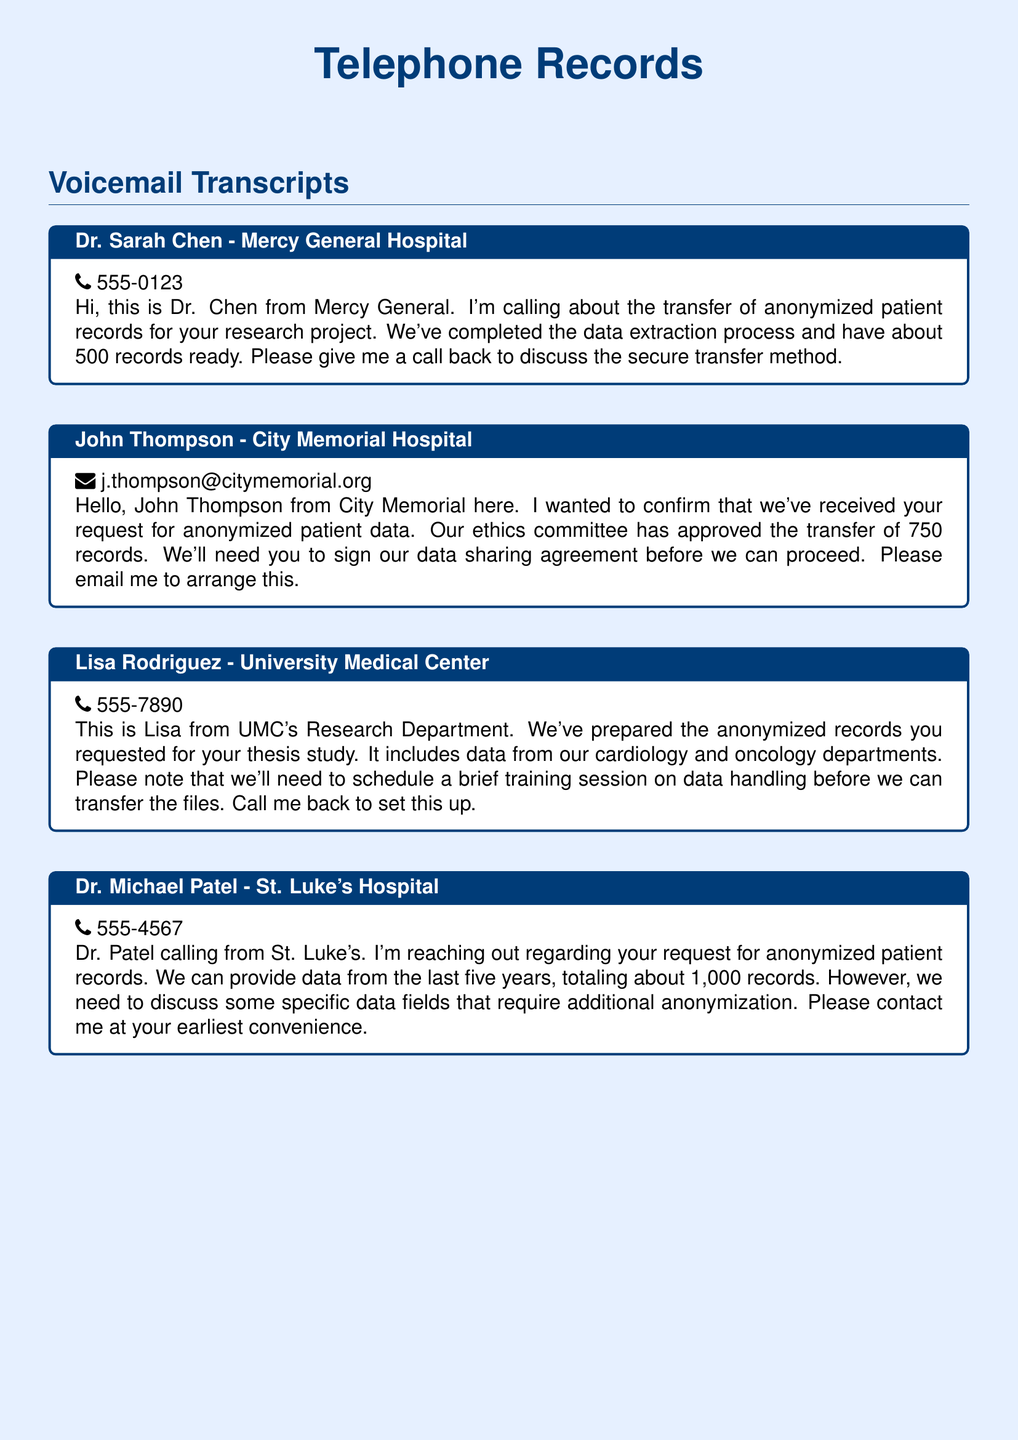What is the name of the first caller? The first caller is Dr. Sarah Chen, identified by the header of the voicemail.
Answer: Dr. Sarah Chen How many records did Mercy General Hospital prepare? The voicemail indicates that Mercy General has approximately 500 records ready for transfer.
Answer: 500 What is required to proceed with the transfer from City Memorial Hospital? The voicemail mentions that a signed data sharing agreement is needed to proceed.
Answer: Data sharing agreement Who is the contact person at University Medical Center? The contact person is Lisa Rodriguez, as stated at the beginning of her voicemail.
Answer: Lisa Rodriguez How many records can St. Luke's Hospital provide? Dr. Patel mentions that they can provide about 1,000 records in his voicemail.
Answer: 1,000 What specific type of training is mentioned by University Medical Center? The voicemail refers to a brief training session on data handling that must be scheduled.
Answer: Data handling How long of a data span can St. Luke's provide? Dr. Patel specifies that the data is from the last five years.
Answer: Last five years What department data is included in the records from University Medical Center? The voicemail states that the records include data from cardiology and oncology departments.
Answer: Cardiology and oncology What action is requested by John Thompson from City Memorial? He requests that you email him to arrange for signing the data sharing agreement.
Answer: Email him to arrange 